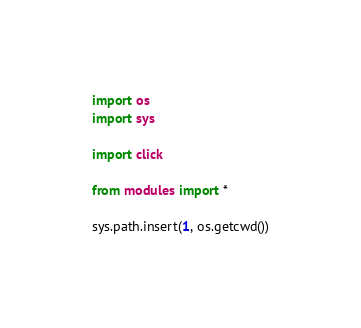<code> <loc_0><loc_0><loc_500><loc_500><_Python_>import os
import sys

import click

from modules import *

sys.path.insert(1, os.getcwd())

</code> 